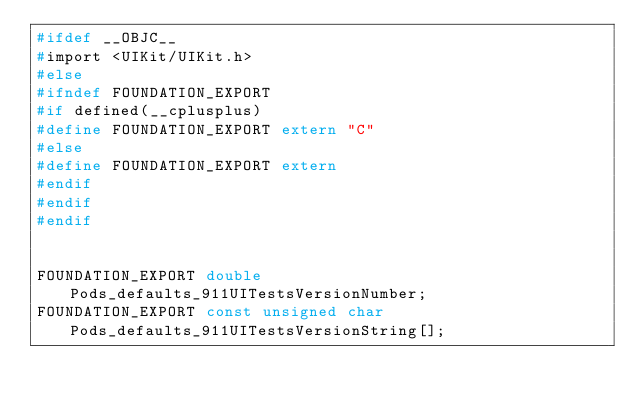Convert code to text. <code><loc_0><loc_0><loc_500><loc_500><_C_>#ifdef __OBJC__
#import <UIKit/UIKit.h>
#else
#ifndef FOUNDATION_EXPORT
#if defined(__cplusplus)
#define FOUNDATION_EXPORT extern "C"
#else
#define FOUNDATION_EXPORT extern
#endif
#endif
#endif


FOUNDATION_EXPORT double Pods_defaults_911UITestsVersionNumber;
FOUNDATION_EXPORT const unsigned char Pods_defaults_911UITestsVersionString[];

</code> 